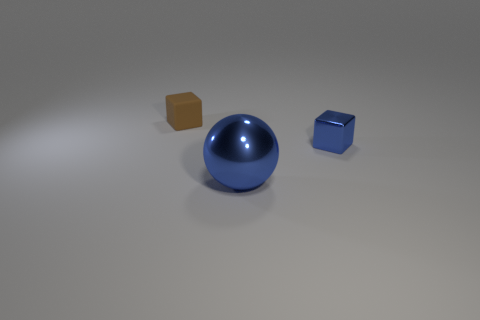What color is the thing that is both in front of the small brown matte object and behind the big ball?
Your response must be concise. Blue. There is a object behind the small blue metal thing; are there any objects in front of it?
Offer a very short reply. Yes. Are there the same number of cubes that are in front of the tiny blue cube and small red matte balls?
Your answer should be compact. Yes. There is a cube in front of the small block to the left of the metallic sphere; how many small blocks are behind it?
Make the answer very short. 1. Is there a blue metal object that has the same size as the rubber cube?
Ensure brevity in your answer.  Yes. Are there fewer large shiny spheres in front of the tiny brown cube than blue metal cylinders?
Keep it short and to the point. No. The tiny thing left of the shiny block that is right of the brown matte block that is on the left side of the blue sphere is made of what material?
Provide a succinct answer. Rubber. Are there more tiny cubes that are right of the brown matte object than blue spheres right of the blue ball?
Your answer should be compact. Yes. How many shiny objects are either large blue balls or things?
Your response must be concise. 2. The tiny object that is the same color as the large sphere is what shape?
Give a very brief answer. Cube. 